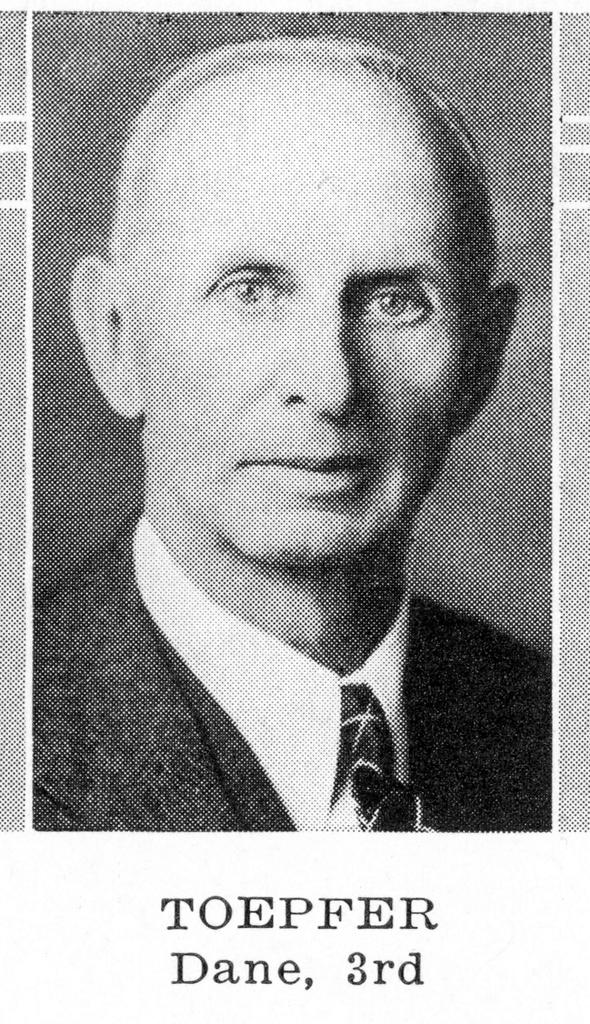What type of photo is in the image? The image contains a passport size photo of a person. What clothing items can be seen on the person in the photo? The person is wearing a coat, a shirt, and a tie. What is the color scheme of the image? The image is black and white. Are there any specific words visible in the image? Yes, there are black color words in the image. Can you see the person's partner in the image? There is no partner visible in the image; it only contains a passport size photo of a person. What type of sand can be seen in the image? There is no sand present in the image; it features a passport size photo of a person. 